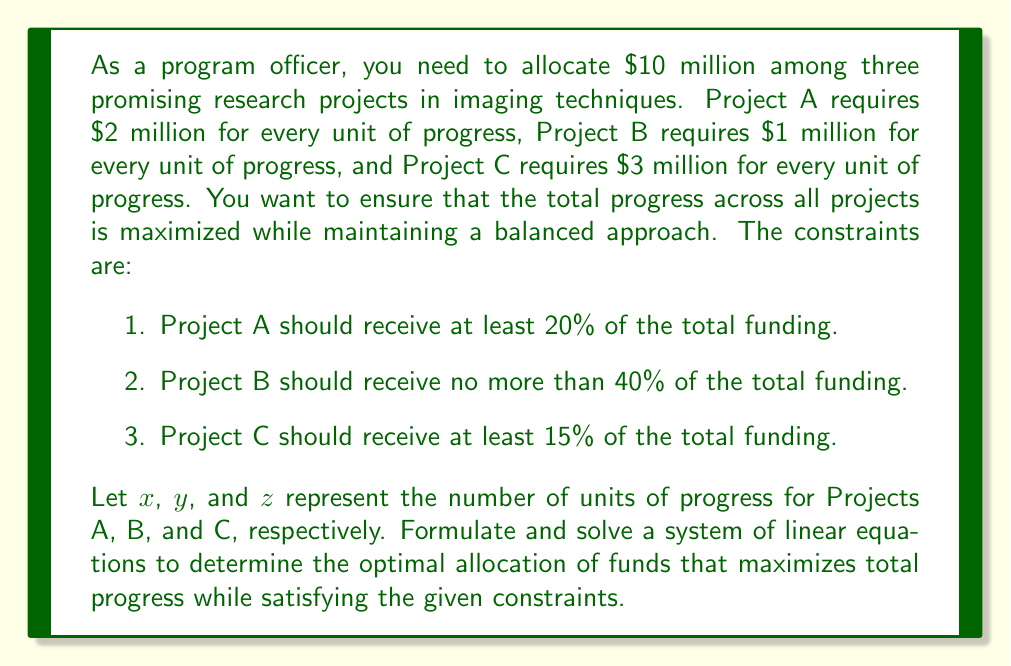Show me your answer to this math problem. Let's approach this problem step by step:

1. First, we need to set up our objective function. We want to maximize the total progress, which is represented by $x + y + z$.

2. Now, let's formulate the constraints as equations:

   a. Total funding constraint: $2x + y + 3z = 10$ (in millions)
   b. Project A constraint: $2x \geq 0.2(10) = 2$
   c. Project B constraint: $y \leq 0.4(10) = 4$
   d. Project C constraint: $3z \geq 0.15(10) = 1.5$

3. We can simplify the last three constraints:
   
   b. $x \geq 1$
   c. $y \leq 4$
   d. $z \geq 0.5$

4. To maximize $x + y + z$ subject to these constraints, we can use the method of linear programming. However, for this problem, we can solve it by reasoning through the constraints.

5. Given that we want to maximize total progress, we should allocate the minimum required funding to Projects A and C, and then allocate the rest to Project B (up to its maximum).

6. For Project A: $x = 1$ (This satisfies the 20% minimum requirement)
   For Project C: $z = 0.5$ (This satisfies the 15% minimum requirement)

7. Substituting these into the total funding constraint:

   $2(1) + y + 3(0.5) = 10$
   $2 + y + 1.5 = 10$
   $y = 6.5$

8. However, Project B can receive at most 4 units of progress. So we adjust:
   $y = 4$

9. Now we can recalculate z:

   $2(1) + 4 + 3z = 10$
   $6 + 3z = 10$
   $3z = 4$
   $z = \frac{4}{3}$

10. Therefore, the optimal allocation is:
    Project A: $x = 1$ unit of progress ($2 million)
    Project B: $y = 4$ units of progress ($4 million)
    Project C: $z = \frac{4}{3}$ units of progress ($4 million)

11. We can verify that this satisfies all constraints:
    - Total funding: $2(1) + 1(4) + 3(\frac{4}{3}) = 2 + 4 + 4 = 10$ million
    - Project A receives 20% of funding
    - Project B receives 40% of funding (maximum allowed)
    - Project C receives 40% of funding (more than the 15% minimum)

The total progress achieved is $1 + 4 + \frac{4}{3} = \frac{19}{3} \approx 6.33$ units.
Answer: The optimal allocation of funds is:
Project A: $2 million (1 unit of progress)
Project B: $4 million (4 units of progress)
Project C: $4 million (\frac{4}{3}$ units of progress)

Total maximum progress: $\frac{19}{3} \approx 6.33$ units 